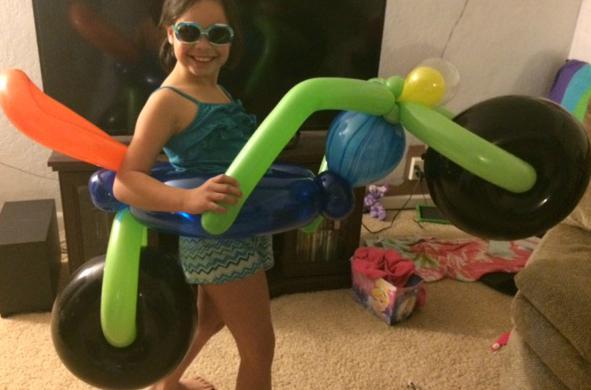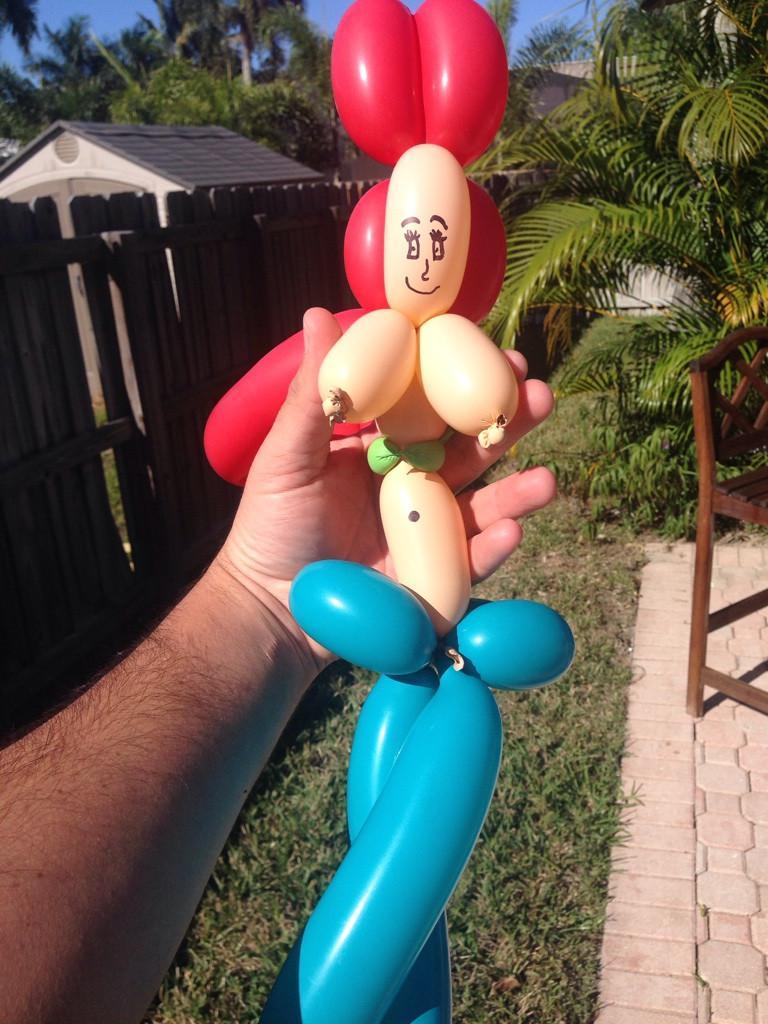The first image is the image on the left, the second image is the image on the right. For the images shown, is this caption "In at least one image there are at least six pink ballons making a skirt." true? Answer yes or no. No. The first image is the image on the left, the second image is the image on the right. Considering the images on both sides, is "The right and left images contain human figures made out of balloons, and one image includes a blond balloon woman wearing a pink skirt." valid? Answer yes or no. No. 